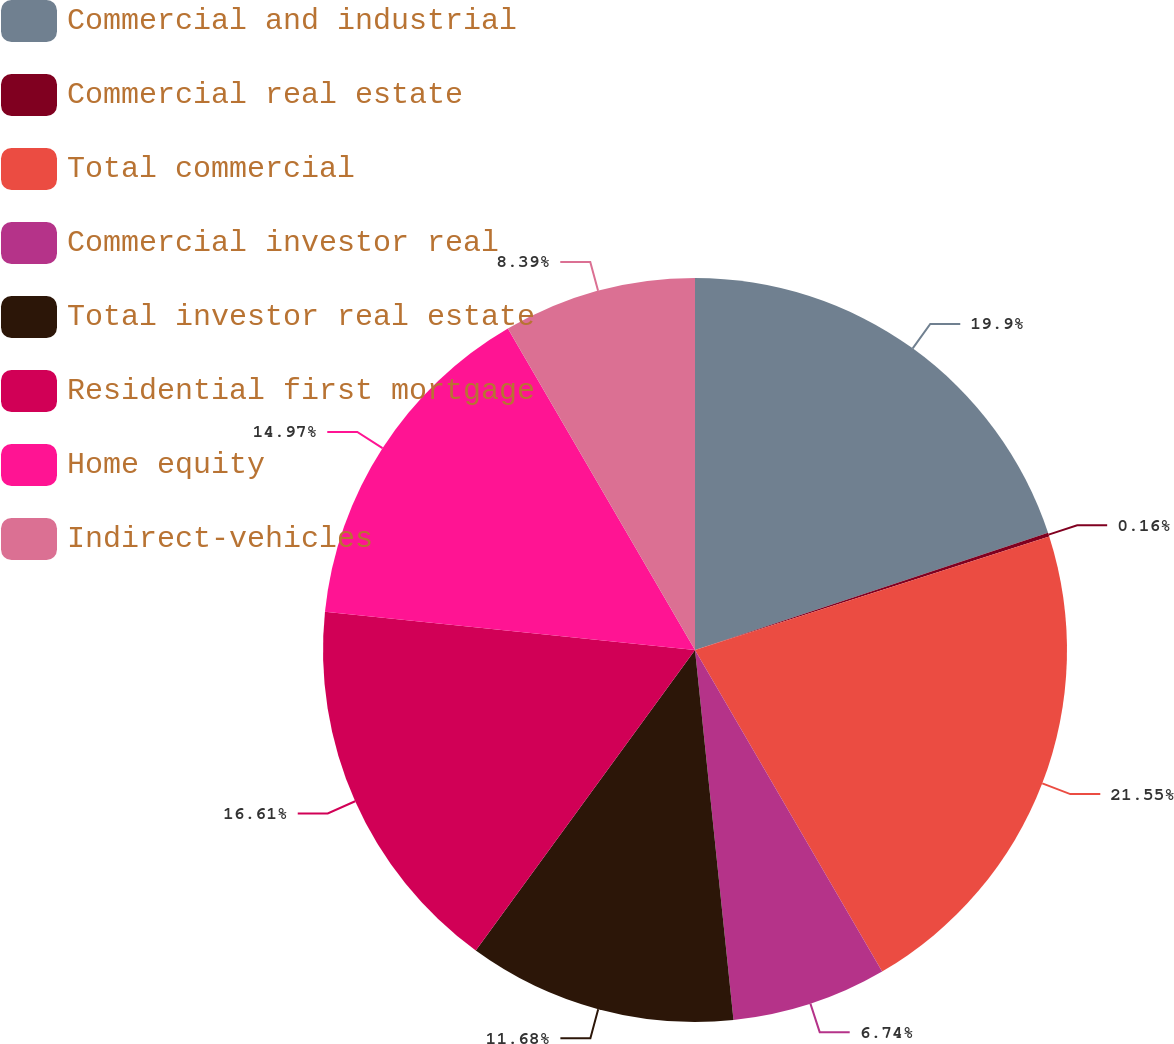Convert chart. <chart><loc_0><loc_0><loc_500><loc_500><pie_chart><fcel>Commercial and industrial<fcel>Commercial real estate<fcel>Total commercial<fcel>Commercial investor real<fcel>Total investor real estate<fcel>Residential first mortgage<fcel>Home equity<fcel>Indirect-vehicles<nl><fcel>19.9%<fcel>0.16%<fcel>21.55%<fcel>6.74%<fcel>11.68%<fcel>16.61%<fcel>14.97%<fcel>8.39%<nl></chart> 